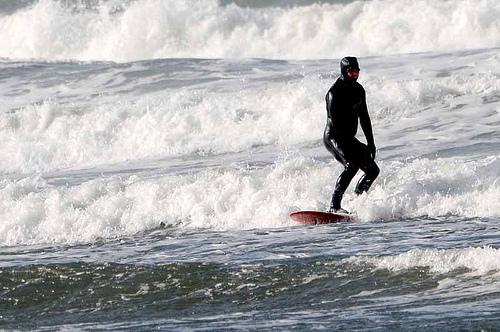Question: why is the man standing on the board?
Choices:
A. He is taking a photo.
B. He is surfing.
C. He is practicing.
D. He is trying to balance.
Answer with the letter. Answer: B Question: what color suit is the man wearing in the picture?
Choices:
A. Grey.
B. Black.
C. Brown.
D. Blue.
Answer with the letter. Answer: B Question: how many surfers are in the picture?
Choices:
A. Two.
B. Three.
C. One.
D. Four.
Answer with the letter. Answer: C Question: where is the water in the picture?
Choices:
A. Under the man's board.
B. Coming off the back of the board.
C. Behind the man.
D. All around.
Answer with the letter. Answer: A Question: when is this picture taken?
Choices:
A. Daytime.
B. Nighttime.
C. The weekend.
D. Christmas.
Answer with the letter. Answer: A Question: who is swimming in the picture?
Choices:
A. A little girl.
B. A mother.
C. No one.
D. A man.
Answer with the letter. Answer: C 